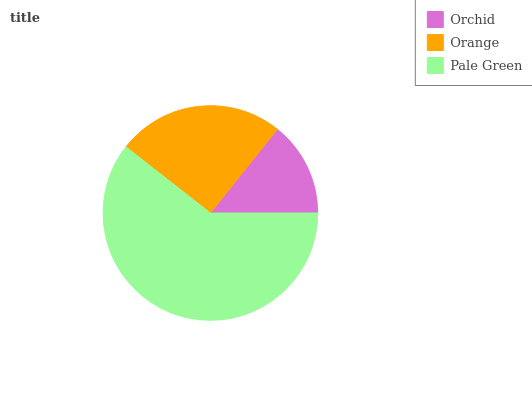Is Orchid the minimum?
Answer yes or no. Yes. Is Pale Green the maximum?
Answer yes or no. Yes. Is Orange the minimum?
Answer yes or no. No. Is Orange the maximum?
Answer yes or no. No. Is Orange greater than Orchid?
Answer yes or no. Yes. Is Orchid less than Orange?
Answer yes or no. Yes. Is Orchid greater than Orange?
Answer yes or no. No. Is Orange less than Orchid?
Answer yes or no. No. Is Orange the high median?
Answer yes or no. Yes. Is Orange the low median?
Answer yes or no. Yes. Is Orchid the high median?
Answer yes or no. No. Is Orchid the low median?
Answer yes or no. No. 